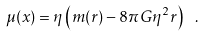Convert formula to latex. <formula><loc_0><loc_0><loc_500><loc_500>\mu ( x ) = \eta \left ( m ( r ) - 8 \pi G \eta ^ { 2 } r \right ) \ .</formula> 